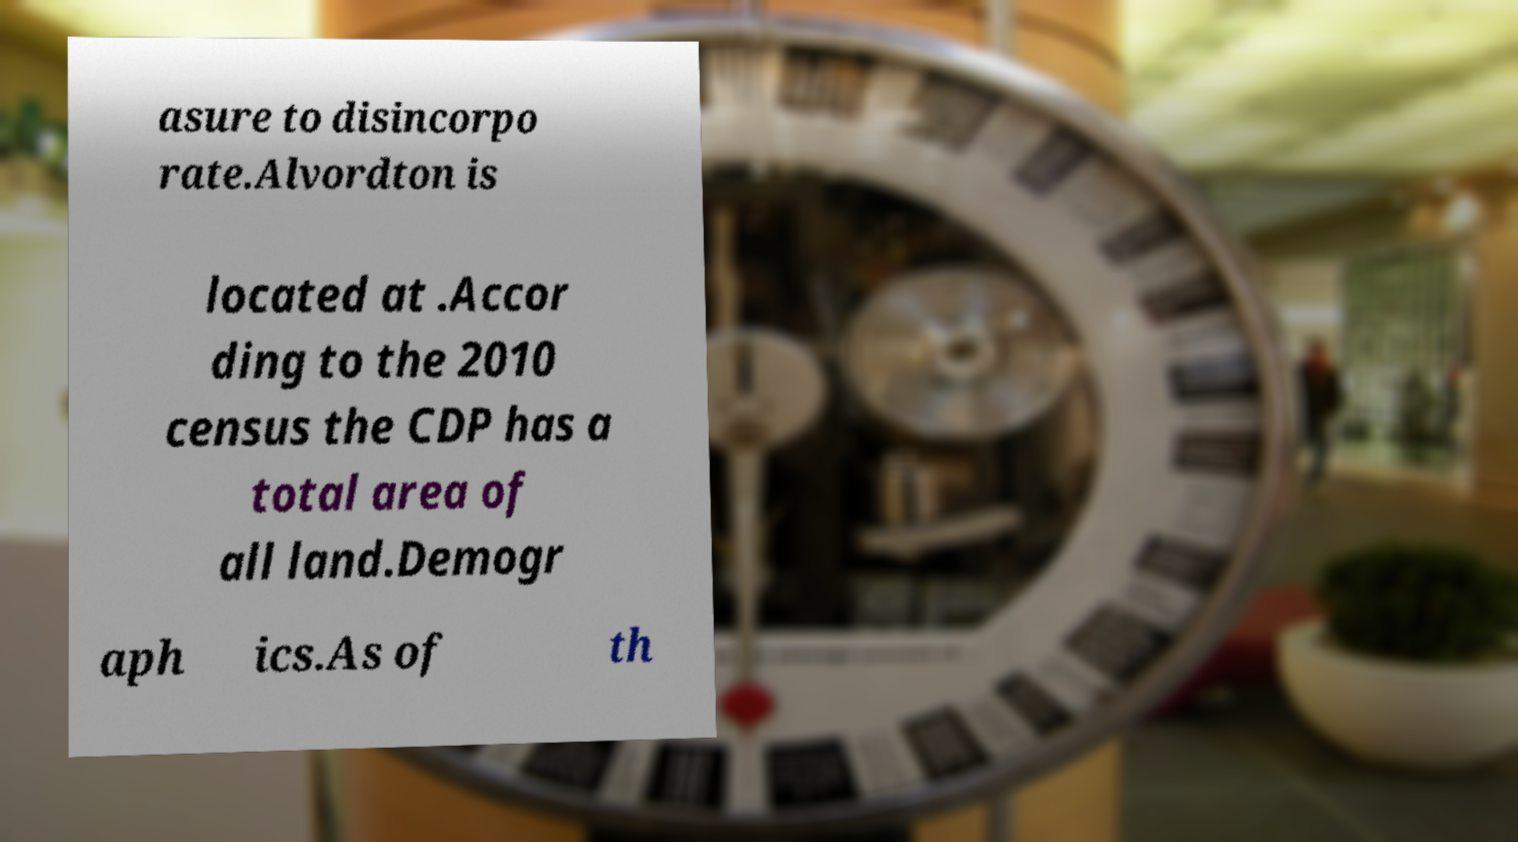For documentation purposes, I need the text within this image transcribed. Could you provide that? asure to disincorpo rate.Alvordton is located at .Accor ding to the 2010 census the CDP has a total area of all land.Demogr aph ics.As of th 